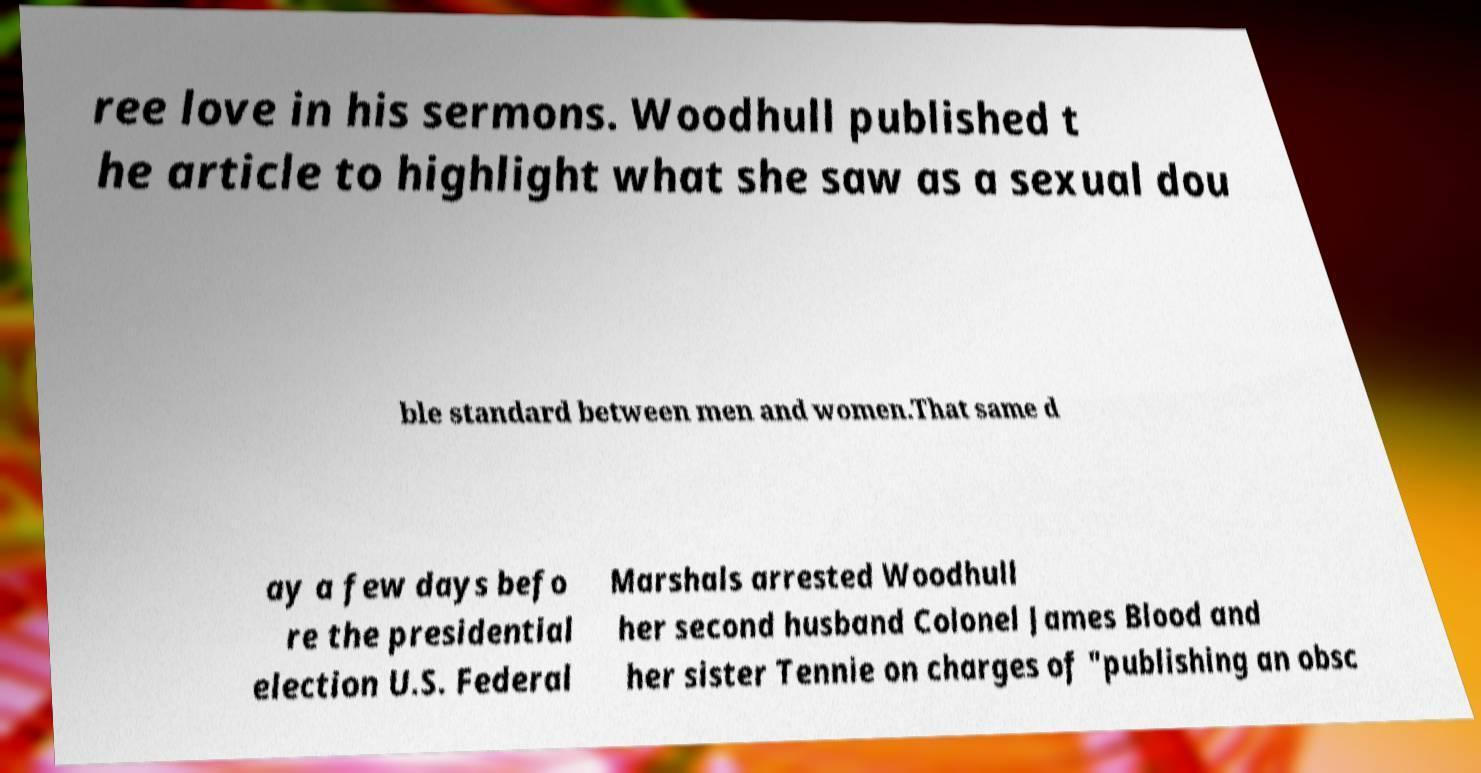Please identify and transcribe the text found in this image. ree love in his sermons. Woodhull published t he article to highlight what she saw as a sexual dou ble standard between men and women.That same d ay a few days befo re the presidential election U.S. Federal Marshals arrested Woodhull her second husband Colonel James Blood and her sister Tennie on charges of "publishing an obsc 